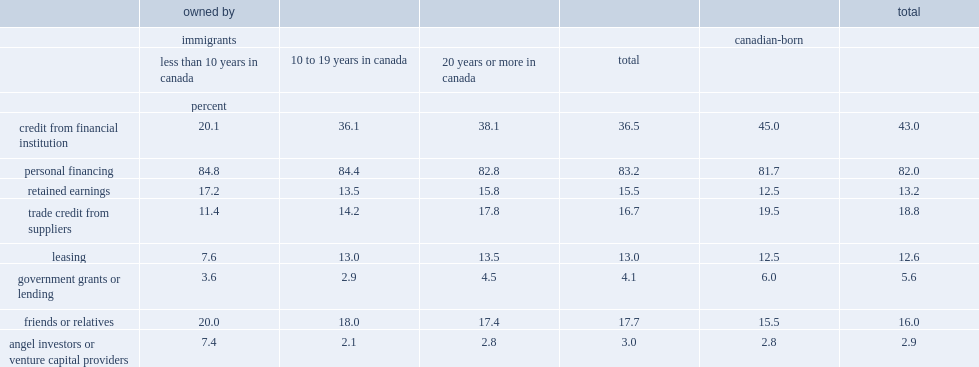Which type of entrepreneur was more likely to turn to credit from financial institution? immigrant entrepreneurs or canadian-born entrepreneurs ? Canadian-born. What percent of immigrants entrepreneurs use loans and equity from "angel investors" or venture capital sources? 3.0. What percent of canadian-born entrepreneurs use government sources of funding to finance start-ups? 6.0. 